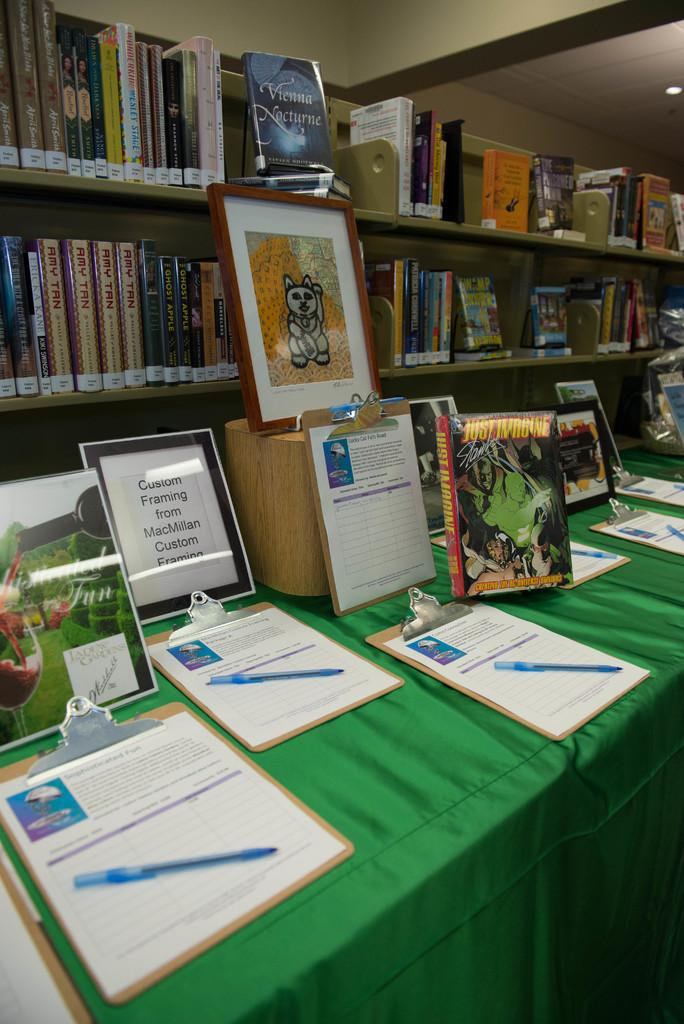<image>
Write a terse but informative summary of the picture. Several items are up for auction on a green table with bidding sheets in front of them including an item for custome framing from MacMillan Custom Framing. 